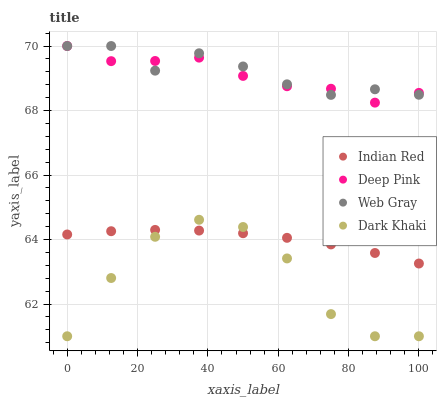Does Dark Khaki have the minimum area under the curve?
Answer yes or no. Yes. Does Web Gray have the maximum area under the curve?
Answer yes or no. Yes. Does Deep Pink have the minimum area under the curve?
Answer yes or no. No. Does Deep Pink have the maximum area under the curve?
Answer yes or no. No. Is Indian Red the smoothest?
Answer yes or no. Yes. Is Dark Khaki the roughest?
Answer yes or no. Yes. Is Deep Pink the smoothest?
Answer yes or no. No. Is Deep Pink the roughest?
Answer yes or no. No. Does Dark Khaki have the lowest value?
Answer yes or no. Yes. Does Deep Pink have the lowest value?
Answer yes or no. No. Does Web Gray have the highest value?
Answer yes or no. Yes. Does Indian Red have the highest value?
Answer yes or no. No. Is Indian Red less than Deep Pink?
Answer yes or no. Yes. Is Web Gray greater than Indian Red?
Answer yes or no. Yes. Does Indian Red intersect Dark Khaki?
Answer yes or no. Yes. Is Indian Red less than Dark Khaki?
Answer yes or no. No. Is Indian Red greater than Dark Khaki?
Answer yes or no. No. Does Indian Red intersect Deep Pink?
Answer yes or no. No. 